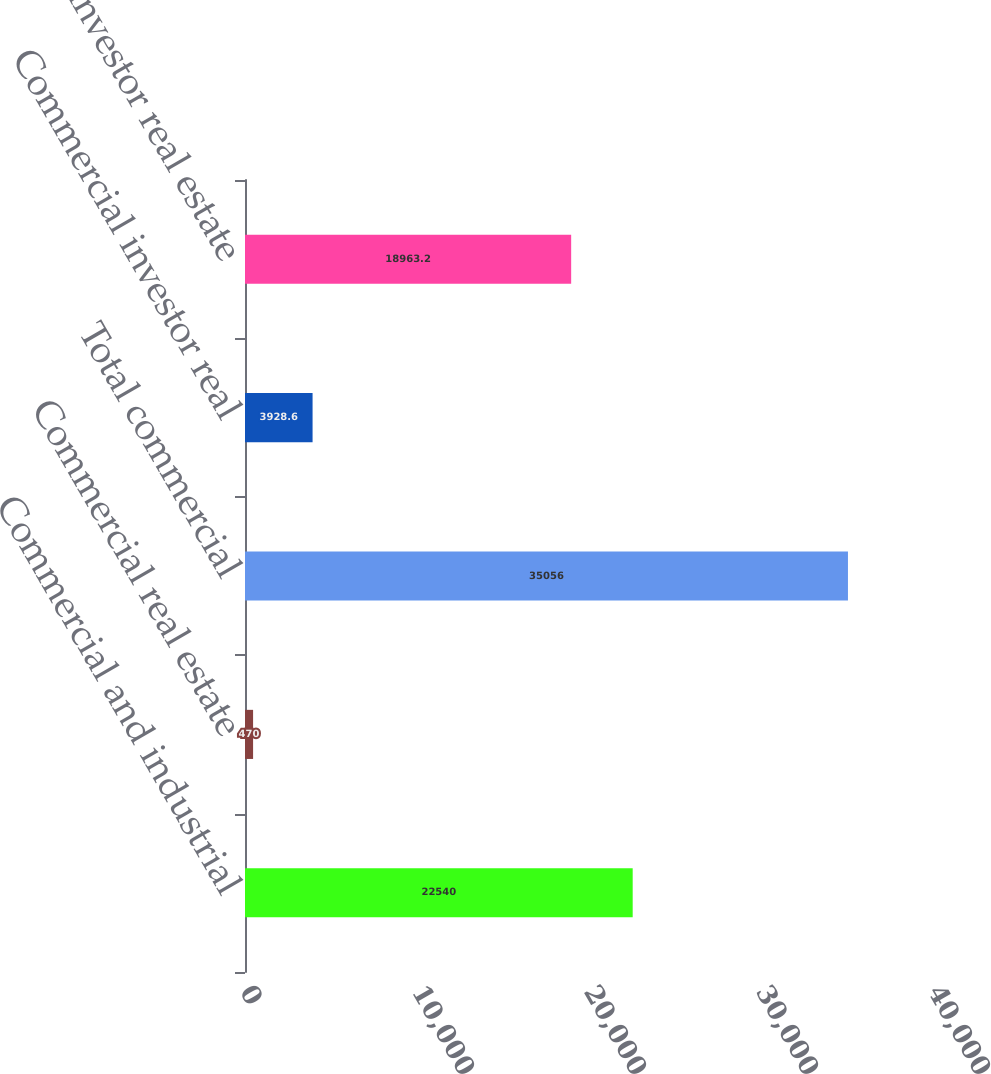Convert chart. <chart><loc_0><loc_0><loc_500><loc_500><bar_chart><fcel>Commercial and industrial<fcel>Commercial real estate<fcel>Total commercial<fcel>Commercial investor real<fcel>Total investor real estate<nl><fcel>22540<fcel>470<fcel>35056<fcel>3928.6<fcel>18963.2<nl></chart> 